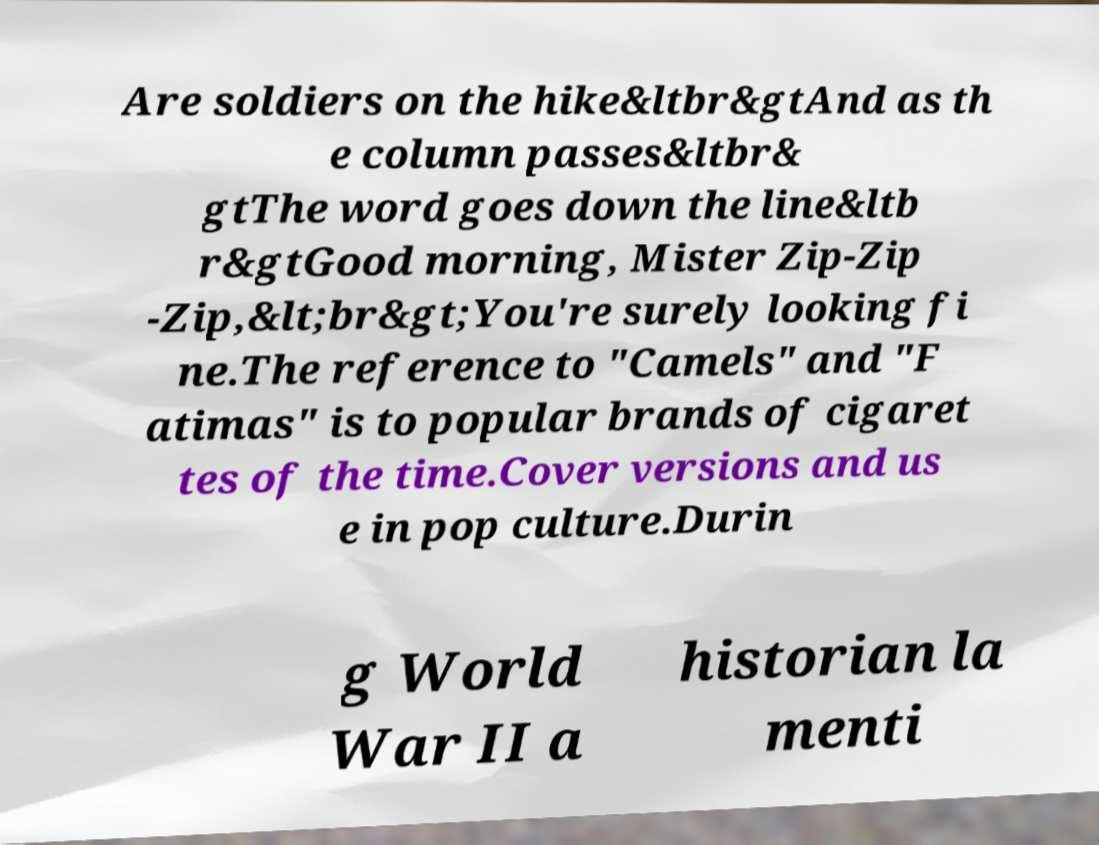Please identify and transcribe the text found in this image. Are soldiers on the hike&ltbr&gtAnd as th e column passes&ltbr& gtThe word goes down the line&ltb r&gtGood morning, Mister Zip-Zip -Zip,&lt;br&gt;You're surely looking fi ne.The reference to "Camels" and "F atimas" is to popular brands of cigaret tes of the time.Cover versions and us e in pop culture.Durin g World War II a historian la menti 